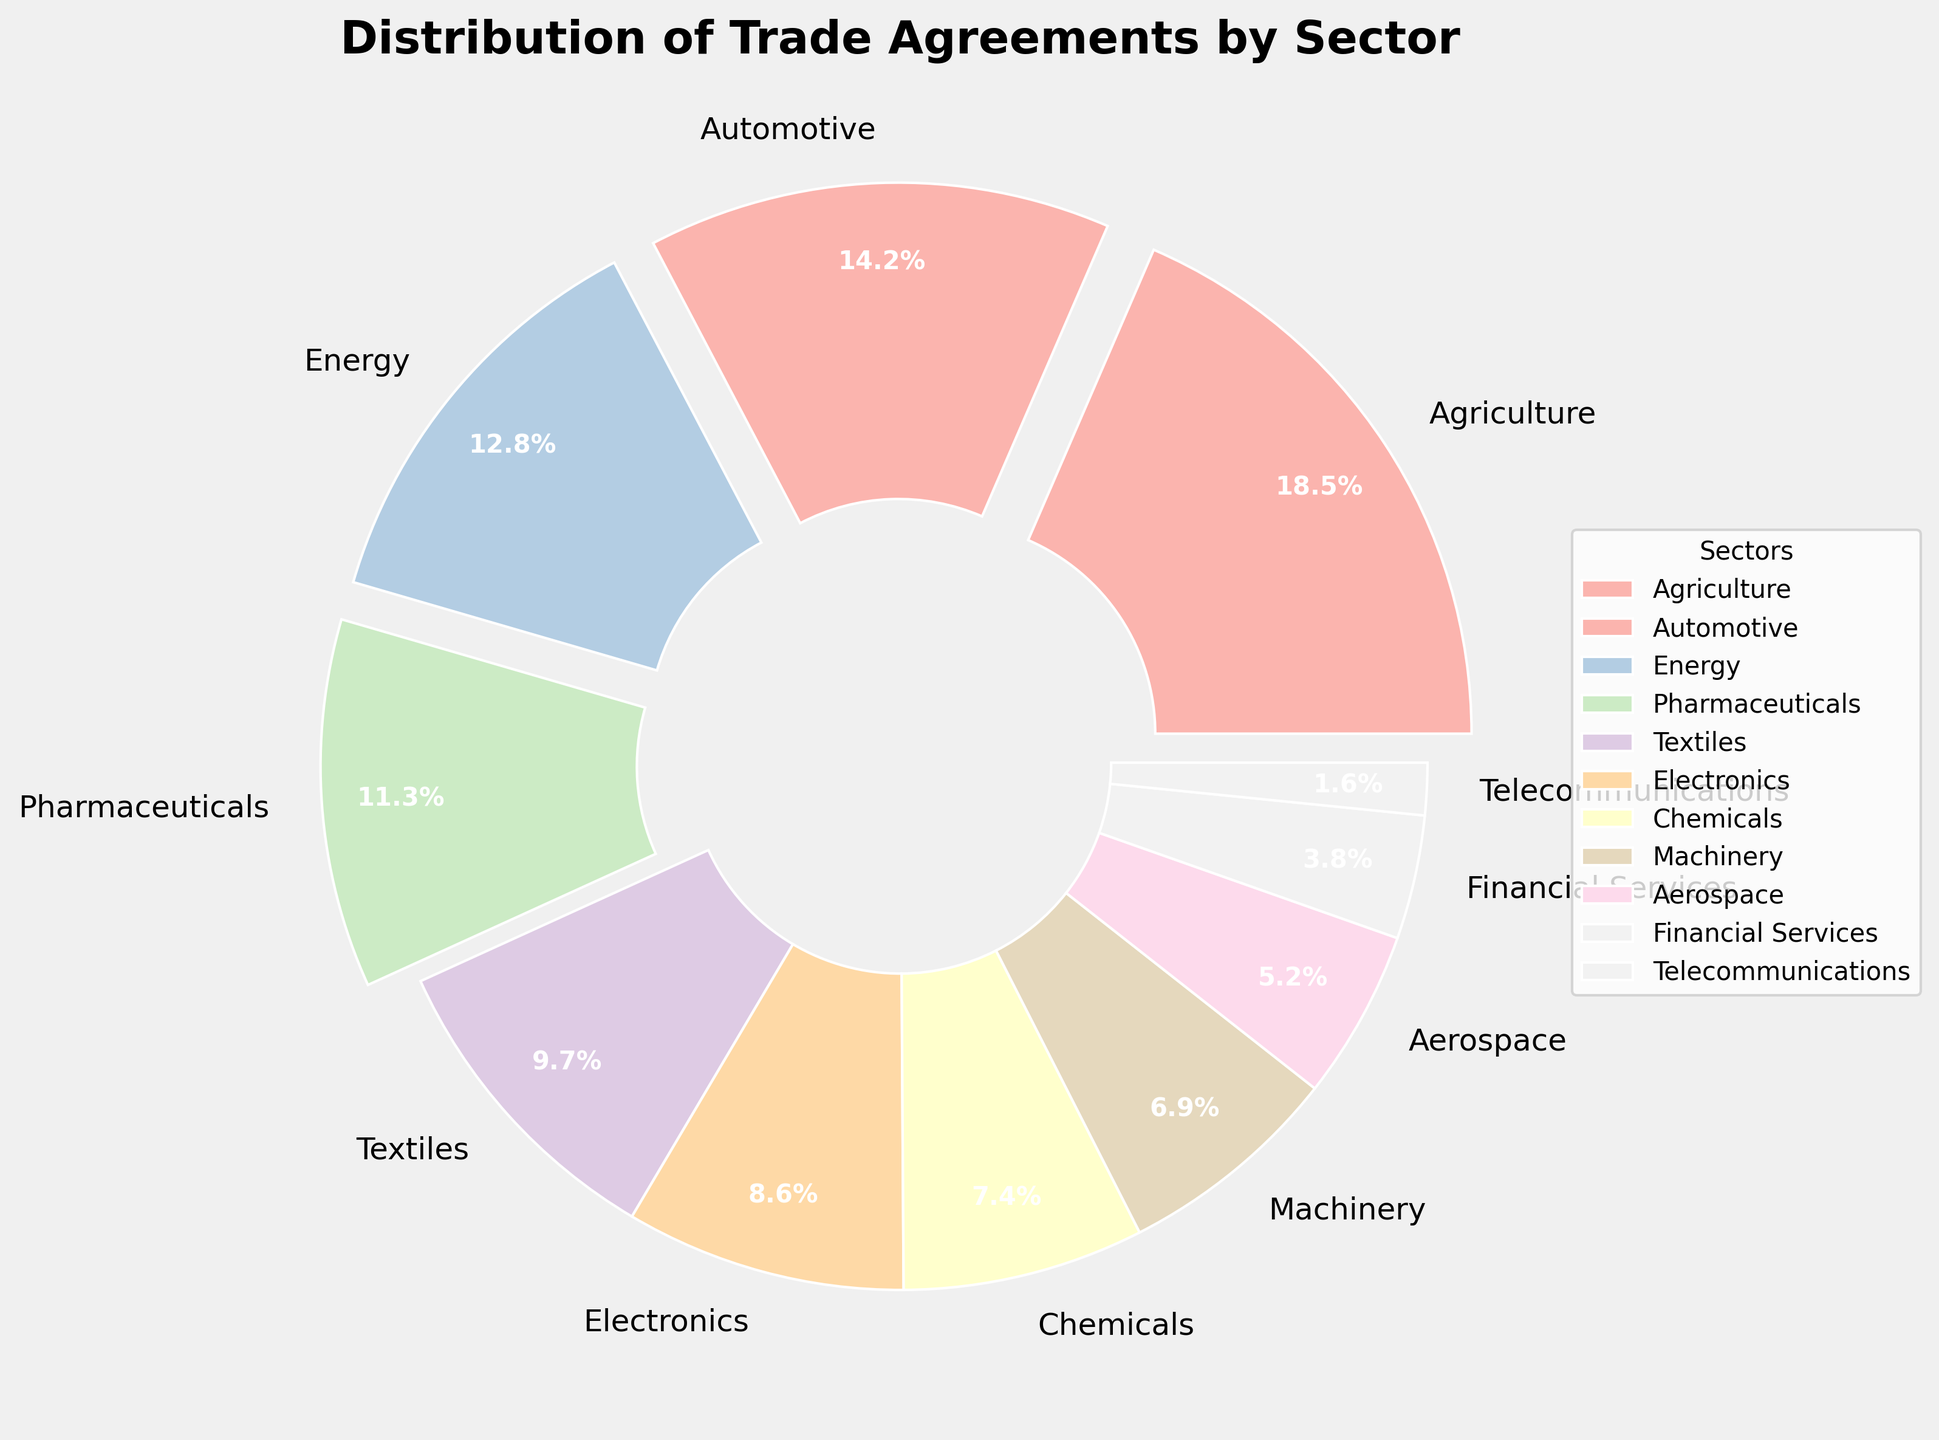which sector has the highest percentage of trade agreements? Refer to the slice with the largest size in the pie chart. The Agriculture sector has the largest percentage, indicating it's the highest.
Answer: Agriculture what is the combined percentage of trade agreements for the energy and pharmaceuticals sectors? Identify and add the percentages for Energy (12.8%) and Pharmaceuticals (11.3%). 12.8% + 11.3% = 24.1%
Answer: 24.1% which sector has less trade agreements, financial services or telecommunications? Compare the percentages of Financial Services (3.8%) and Telecommunications (1.6%). Telecommunications has a lower percentage.
Answer: Telecommunications what is the percentage difference between the automotive and aerospace sectors? Subtract the percentage of the Aerospace sector (5.2%) from that of the Automotive sector (14.2%). 14.2% - 5.2% = 9%
Answer: 9% how many sectors have a percentage higher than 10%? Count the sectors with percentages above 10%: Agriculture (18.5%), Automotive (14.2%), Energy (12.8%), Pharmaceuticals (11.3%). There are four sectors.
Answer: 4 is the percentage of trade agreements for the textiles sector greater than that for the electronics sector? Compare the percentages of Textiles (9.7%) and Electronics (8.6%). Textiles has a higher percentage.
Answer: Yes what is the percentage of trade agreements for the top 3 sectors combined? Sum up the percentages for the top 3 sectors: Agriculture (18.5%), Automotive (14.2%), Energy (12.8%). 18.5% + 14.2% + 12.8% = 45.5%
Answer: 45.5% which sectors have their wedges exploded in the pie chart? Identify wedges further separated from the center, which typically denote significant values: Agriculture, Automotive, Energy, and Pharmaceuticals as each has a percentage higher than 10%.
Answer: Agriculture, Automotive, Energy, Pharmaceuticals what percentage of the trade agreements does the bottom 3 sectors collectively represent? Sum up percentages for the bottom 3 sectors: Aerospace (5.2%), Financial Services (3.8%), Telecommunications (1.6%). 5.2% + 3.8% + 1.6% = 10.6%
Answer: 10.6% compare the percentage of trade agreements in the chemicals sector to that in the machinery sector. Check the percentages: Chemicals (7.4%) vs. Machinery (6.9%). Chemicals has a slightly higher percentage than Machinery.
Answer: Chemicals 